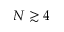<formula> <loc_0><loc_0><loc_500><loc_500>N \gtrsim 4</formula> 